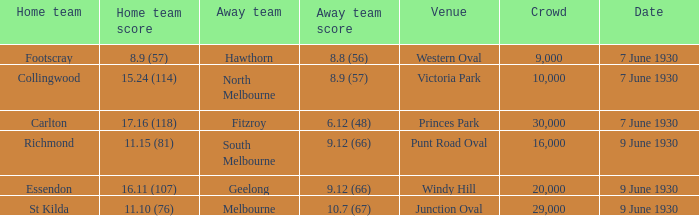What is the average crowd to watch Hawthorn as the away team? 9000.0. 